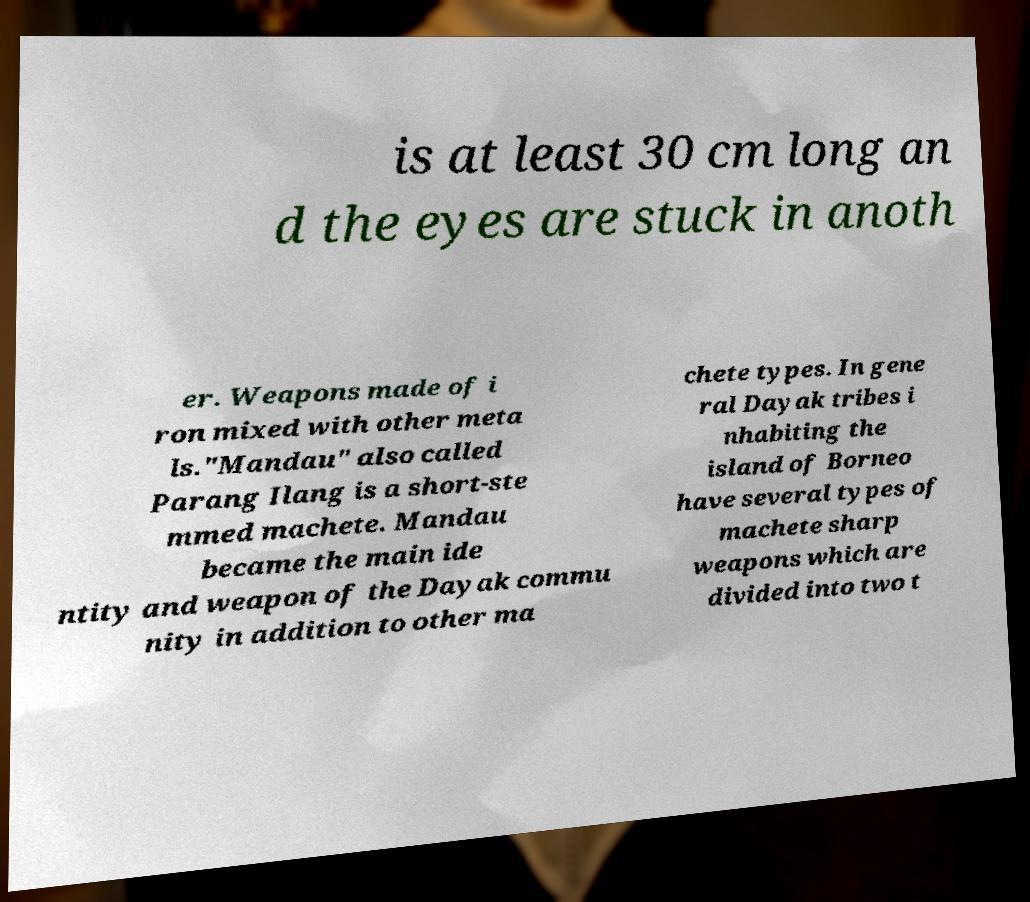Could you extract and type out the text from this image? is at least 30 cm long an d the eyes are stuck in anoth er. Weapons made of i ron mixed with other meta ls."Mandau" also called Parang Ilang is a short-ste mmed machete. Mandau became the main ide ntity and weapon of the Dayak commu nity in addition to other ma chete types. In gene ral Dayak tribes i nhabiting the island of Borneo have several types of machete sharp weapons which are divided into two t 